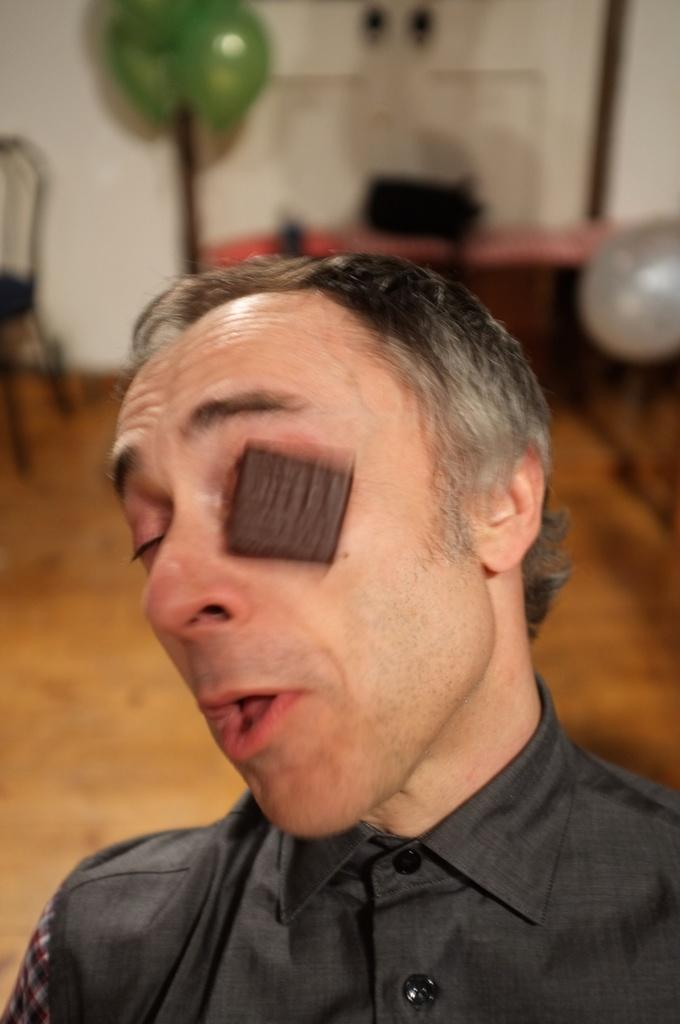Who is the main subject in the front of the image? There is a man in the front of the image. What objects can be seen in the background of the image? There is a table, a chair, balloons, and a white color wall in the background of the image. What advice does the picture in the background of the image offer? There is no picture present in the image to offer any advice. 